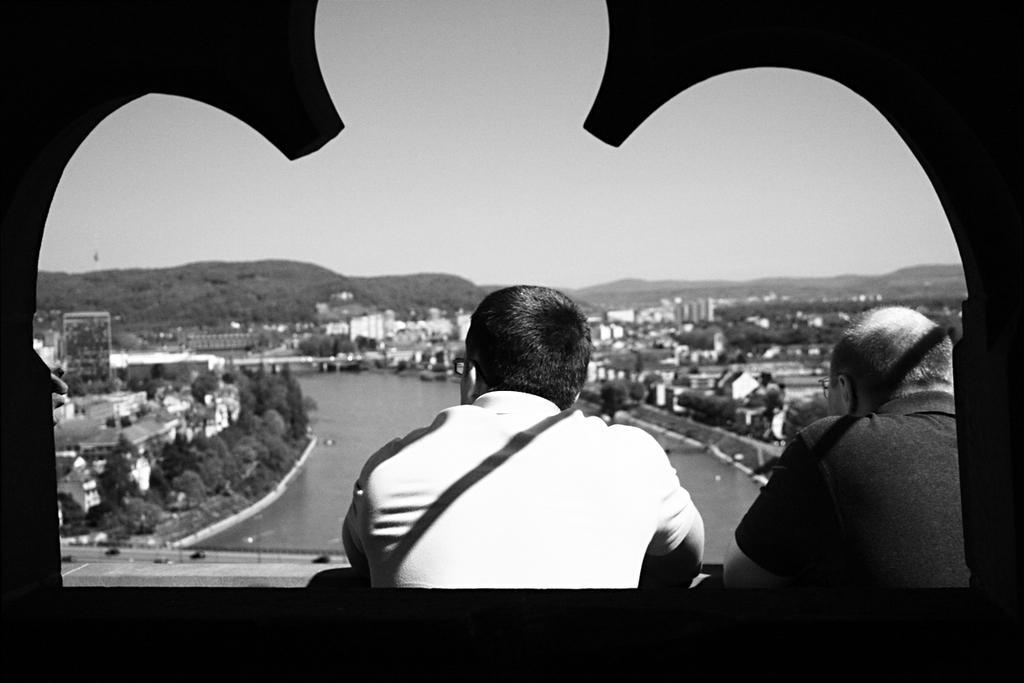Could you give a brief overview of what you see in this image? In this image I can see two person. Back Side I can see trees,buildings and water. We can see mountain. The image is in black and white. 